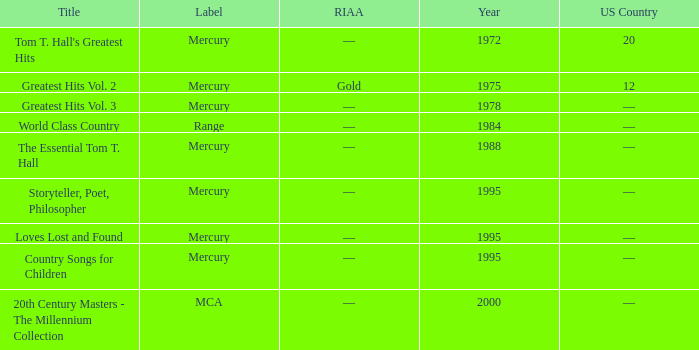What is the highest year for the title, "loves lost and found"? 1995.0. Could you parse the entire table? {'header': ['Title', 'Label', 'RIAA', 'Year', 'US Country'], 'rows': [["Tom T. Hall's Greatest Hits", 'Mercury', '—', '1972', '20'], ['Greatest Hits Vol. 2', 'Mercury', 'Gold', '1975', '12'], ['Greatest Hits Vol. 3', 'Mercury', '—', '1978', '—'], ['World Class Country', 'Range', '—', '1984', '—'], ['The Essential Tom T. Hall', 'Mercury', '—', '1988', '—'], ['Storyteller, Poet, Philosopher', 'Mercury', '—', '1995', '—'], ['Loves Lost and Found', 'Mercury', '—', '1995', '—'], ['Country Songs for Children', 'Mercury', '—', '1995', '—'], ['20th Century Masters - The Millennium Collection', 'MCA', '—', '2000', '—']]} 